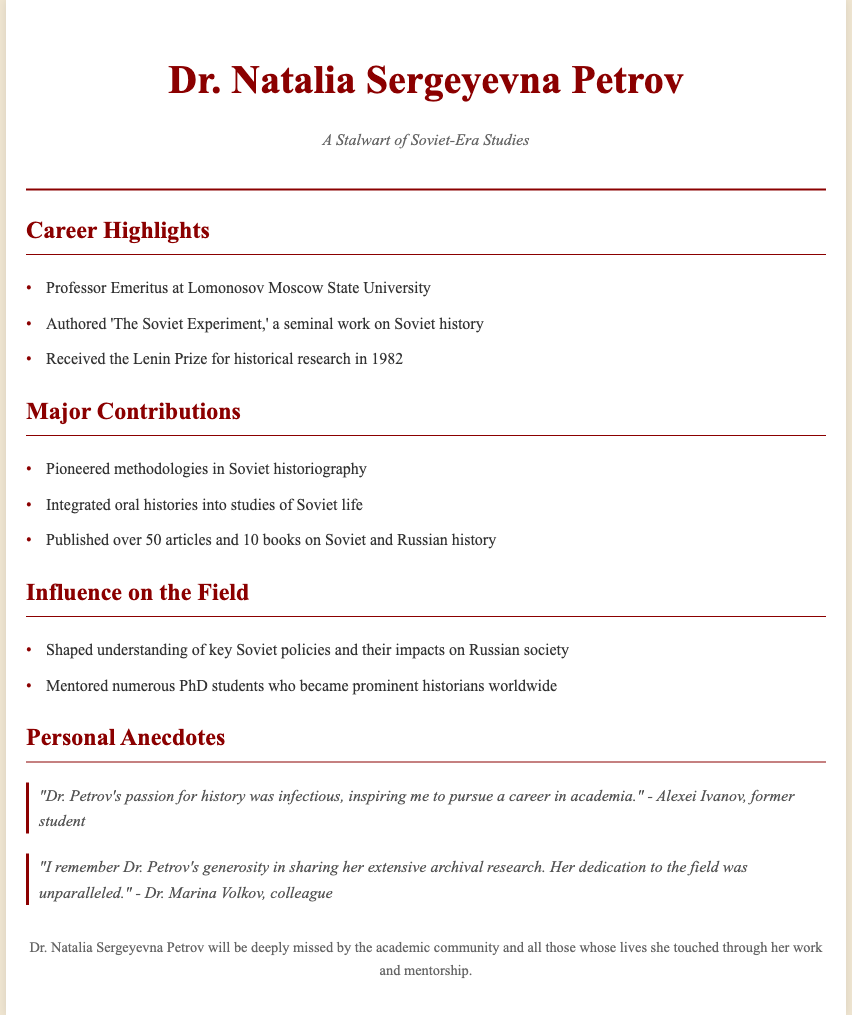What is the full name of the historian? The document provides the full name of the historian as "Dr. Natalia Sergeyevna Petrov."
Answer: Dr. Natalia Sergeyevna Petrov What is the subtitle of the obituary? The subtitle under the title indicates her significance in the field, labeled as "A Stalwart of Soviet-Era Studies."
Answer: A Stalwart of Soviet-Era Studies Where was Dr. Petrov a professor? The document states that she was a "Professor Emeritus at Lomonosov Moscow State University."
Answer: Lomonosov Moscow State University In which year did Dr. Petrov receive the Lenin Prize? The document specifically mentions that she received the prize in "1982."
Answer: 1982 How many books did Dr. Petrov publish? The document notes that she published "10 books on Soviet and Russian history."
Answer: 10 books What methodology did Dr. Petrov pioneer? The document indicates she "Pioneered methodologies in Soviet historiography."
Answer: Methodologies in Soviet historiography What impact did she have on her PhD students? According to the document, she "Mentored numerous PhD students who became prominent historians worldwide."
Answer: Prominent historians worldwide What did Alexei Ivanov say about Dr. Petrov? The document includes a quote where Alexei Ivanov mentioned her "passion for history was infectious."
Answer: Passion for history was infectious What prize was mentioned in relation to her achievements? The obituary highlights the "Lenin Prize for historical research."
Answer: Lenin Prize for historical research 